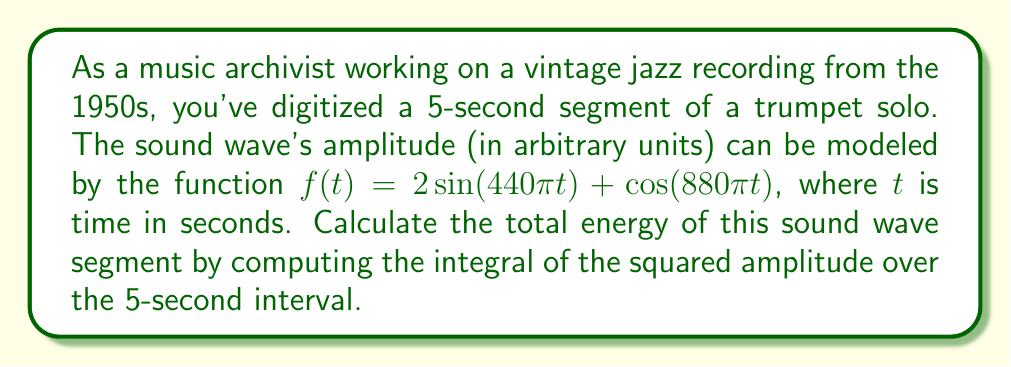What is the answer to this math problem? To solve this problem, we'll follow these steps:

1) The energy of a sound wave is proportional to the integral of the squared amplitude over time. We need to integrate $[f(t)]^2$ from $t=0$ to $t=5$.

2) Let's expand $[f(t)]^2$:

   $[f(t)]^2 = [2\sin(440\pi t) + \cos(880\pi t)]^2$
   $= 4\sin^2(440\pi t) + 4\sin(440\pi t)\cos(880\pi t) + \cos^2(880\pi t)$

3) Now, we need to integrate this from 0 to 5:

   $\int_0^5 [f(t)]^2 dt = \int_0^5 [4\sin^2(440\pi t) + 4\sin(440\pi t)\cos(880\pi t) + \cos^2(880\pi t)] dt$

4) Let's break this into three integrals:

   $I_1 = \int_0^5 4\sin^2(440\pi t) dt$
   $I_2 = \int_0^5 4\sin(440\pi t)\cos(880\pi t) dt$
   $I_3 = \int_0^5 \cos^2(880\pi t) dt$

5) For $I_1$, we can use the identity $\sin^2(x) = \frac{1}{2}(1-\cos(2x))$:

   $I_1 = \int_0^5 4 \cdot \frac{1}{2}(1-\cos(880\pi t)) dt = \int_0^5 2 - 2\cos(880\pi t) dt$
   $= [2t + \frac{2}{880\pi}\sin(880\pi t)]_0^5 = 10 + 0 - 0 = 10$

6) For $I_2$, we can use the trigonometric product-to-sum formula:

   $\sin(A)\cos(B) = \frac{1}{2}[\sin(A-B) + \sin(A+B)]$

   $I_2 = \int_0^5 4 \cdot \frac{1}{2}[\sin(-440\pi t) + \sin(1320\pi t)] dt$
   $= [-\frac{2}{440\pi}\cos(-440\pi t) + \frac{2}{1320\pi}\cos(1320\pi t)]_0^5$
   $= [0 + 0] - [-\frac{2}{440\pi} + \frac{2}{1320\pi}] = \frac{1}{220\pi} - \frac{1}{660\pi} = \frac{1}{330\pi}$

7) For $I_3$, we can use the identity $\cos^2(x) = \frac{1}{2}(1+\cos(2x))$:

   $I_3 = \int_0^5 \frac{1}{2}(1+\cos(1760\pi t)) dt$
   $= [\frac{1}{2}t + \frac{1}{3520\pi}\sin(1760\pi t)]_0^5 = \frac{5}{2} + 0 - 0 = \frac{5}{2}$

8) The total energy is the sum of these three integrals:

   $E = I_1 + I_2 + I_3 = 10 + \frac{1}{330\pi} + \frac{5}{2} = \frac{25}{2} + \frac{1}{330\pi}$
Answer: $\frac{25}{2} + \frac{1}{330\pi}$ 